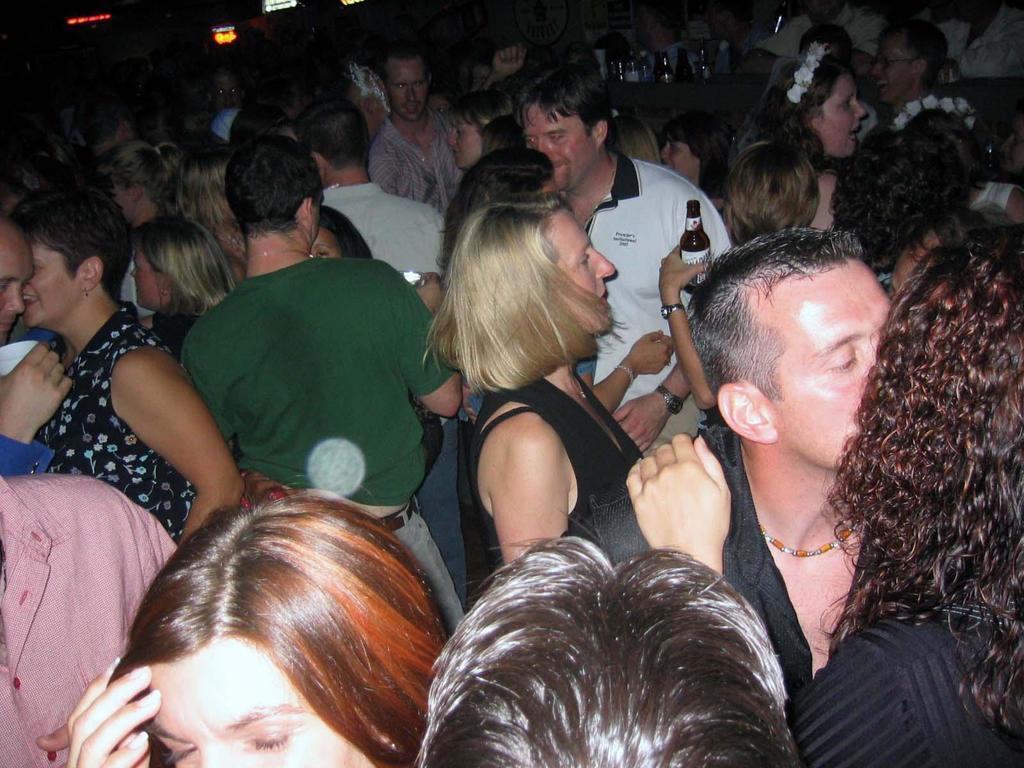Describe this image in one or two sentences. In this picture we can see there are groups of people standing and a person is holding a bottle. Behind the people there are bottles on an object and a dark background. 